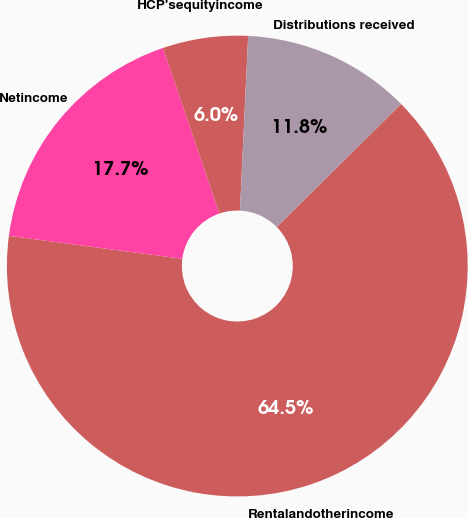<chart> <loc_0><loc_0><loc_500><loc_500><pie_chart><fcel>Rentalandotherincome<fcel>Netincome<fcel>HCP'sequityincome<fcel>Distributions received<nl><fcel>64.51%<fcel>17.68%<fcel>5.98%<fcel>11.83%<nl></chart> 